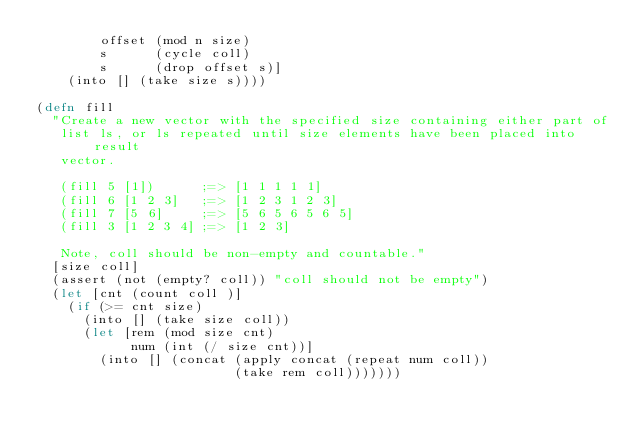<code> <loc_0><loc_0><loc_500><loc_500><_Clojure_>        offset (mod n size)
        s      (cycle coll)
        s      (drop offset s)]
    (into [] (take size s))))

(defn fill
  "Create a new vector with the specified size containing either part of
   list ls, or ls repeated until size elements have been placed into result
   vector.

   (fill 5 [1])      ;=> [1 1 1 1 1]
   (fill 6 [1 2 3]   ;=> [1 2 3 1 2 3]
   (fill 7 [5 6]     ;=> [5 6 5 6 5 6 5]
   (fill 3 [1 2 3 4] ;=> [1 2 3]

   Note, coll should be non-empty and countable."
  [size coll]
  (assert (not (empty? coll)) "coll should not be empty")
  (let [cnt (count coll )]
    (if (>= cnt size)
      (into [] (take size coll))
      (let [rem (mod size cnt)
            num (int (/ size cnt))]
        (into [] (concat (apply concat (repeat num coll))
                         (take rem coll)))))))
</code> 